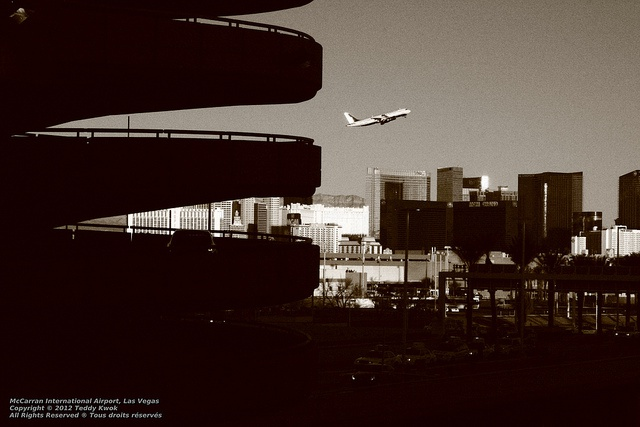Describe the objects in this image and their specific colors. I can see car in black, gray, and lightgray tones, car in black and maroon tones, airplane in black, white, darkgray, and gray tones, car in black and gray tones, and car in black, lightgray, darkgray, and gray tones in this image. 